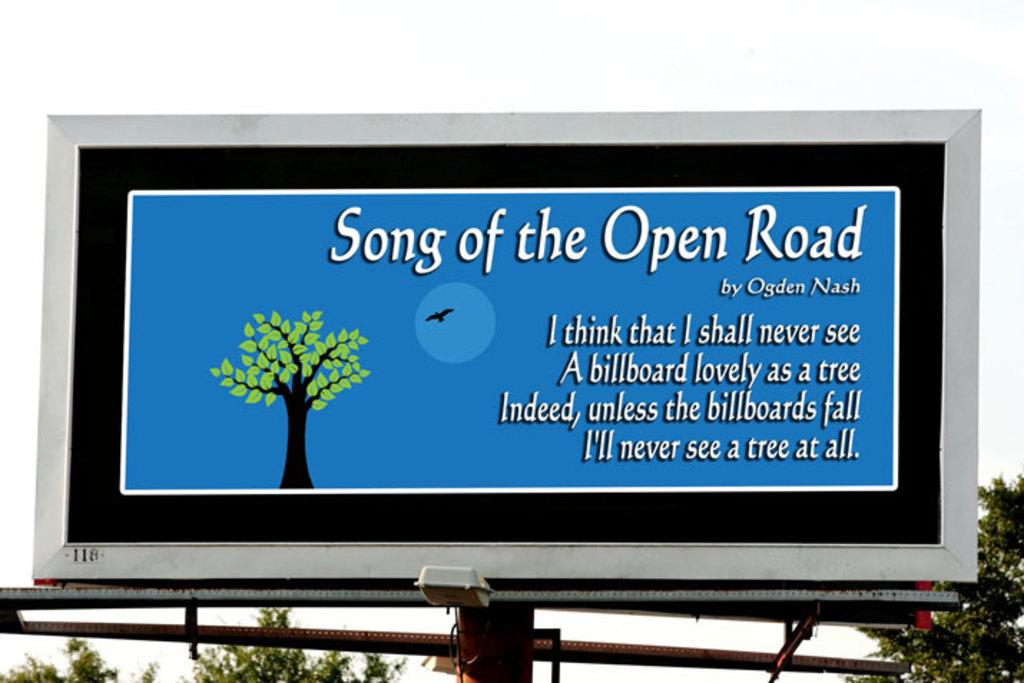<image>
Present a compact description of the photo's key features. A sign has a tree on it and the words song of the open road across the top. 